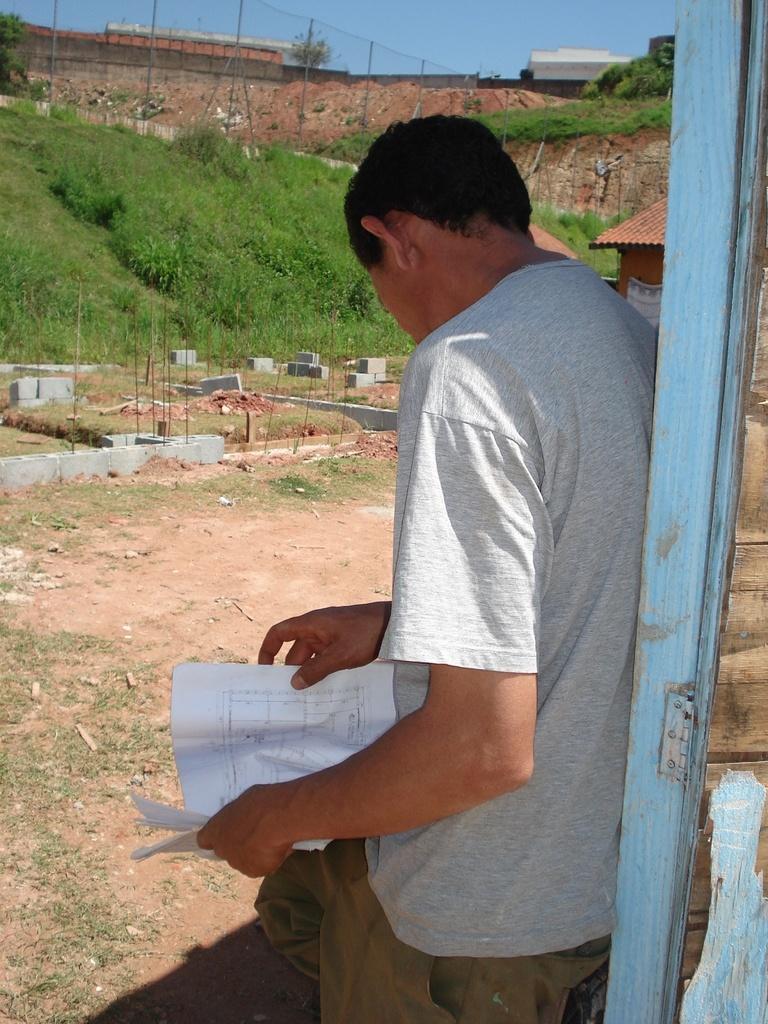How would you summarize this image in a sentence or two? In this picture I can see there is a man standing and he is holding a paper in his hand and there is a wooden door and there are plants, a fence and the sky is clear. 